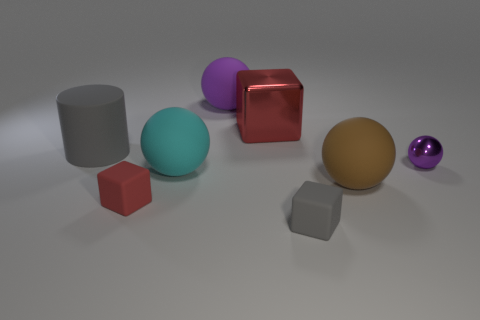What number of other things are the same size as the brown matte ball?
Provide a succinct answer. 4. There is a big thing to the right of the gray object that is on the right side of the matte cylinder; what shape is it?
Provide a succinct answer. Sphere. There is a red block behind the gray matte cylinder; is it the same size as the cyan rubber object?
Your response must be concise. Yes. What number of other things are made of the same material as the big red thing?
Offer a terse response. 1. What number of blue things are either metallic balls or tiny objects?
Ensure brevity in your answer.  0. The other matte block that is the same color as the large block is what size?
Ensure brevity in your answer.  Small. There is a brown matte thing; how many rubber spheres are behind it?
Your answer should be compact. 2. There is a red block that is in front of the rubber sphere that is to the left of the purple ball that is behind the big gray rubber thing; what is its size?
Provide a short and direct response. Small. Is there a cyan object on the right side of the small cube that is behind the gray matte object that is in front of the tiny purple thing?
Your answer should be very brief. Yes. Is the number of gray cylinders greater than the number of metal things?
Offer a terse response. No. 